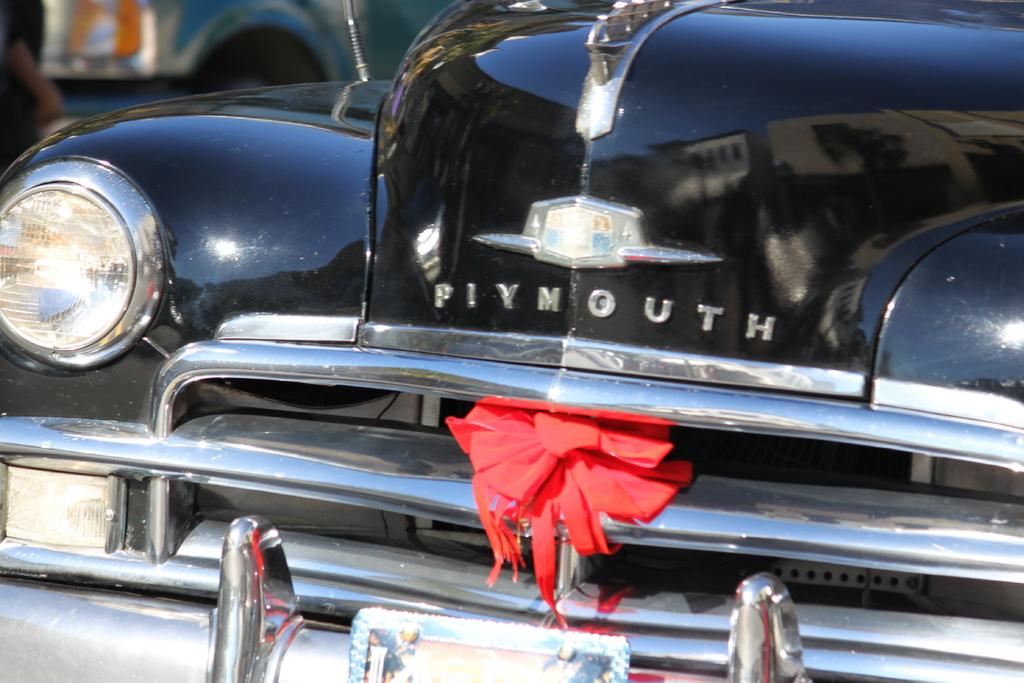What is the main subject of the picture? The main subject of the picture is a vehicle. What color is the vehicle? The vehicle is black in color. How is the background of the vehicle depicted in the image? The background of the vehicle is blurred. How many heads of lettuce can be seen in the picture? There are no heads of lettuce present in the image; it features a black vehicle with a blurred background. 